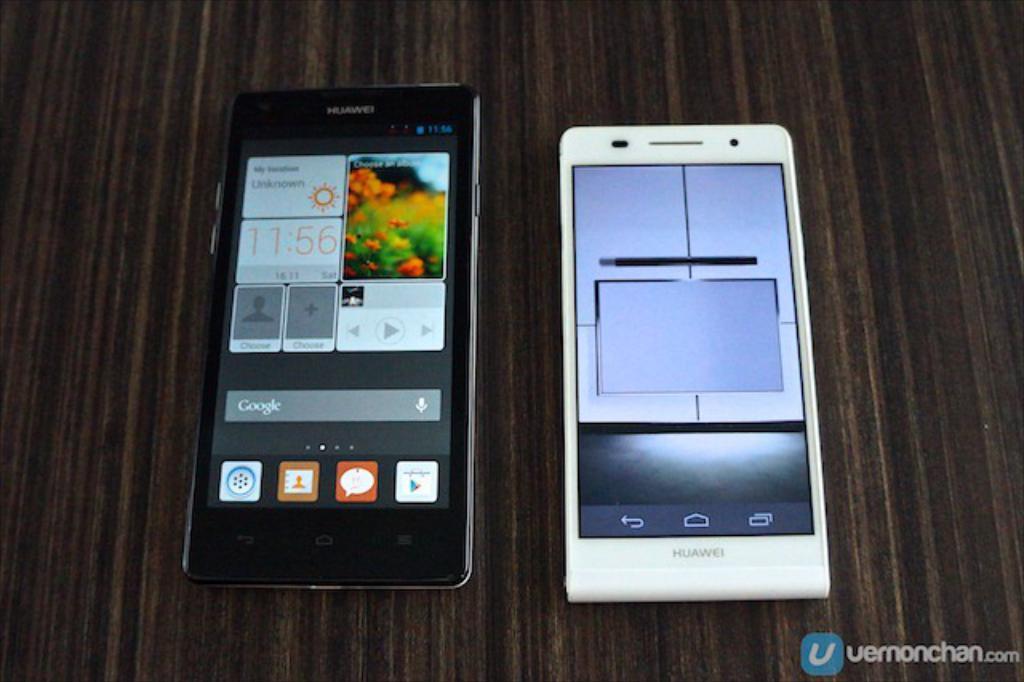<image>
Provide a brief description of the given image. Two cellphones are seen in a Vernonchan.com image. 